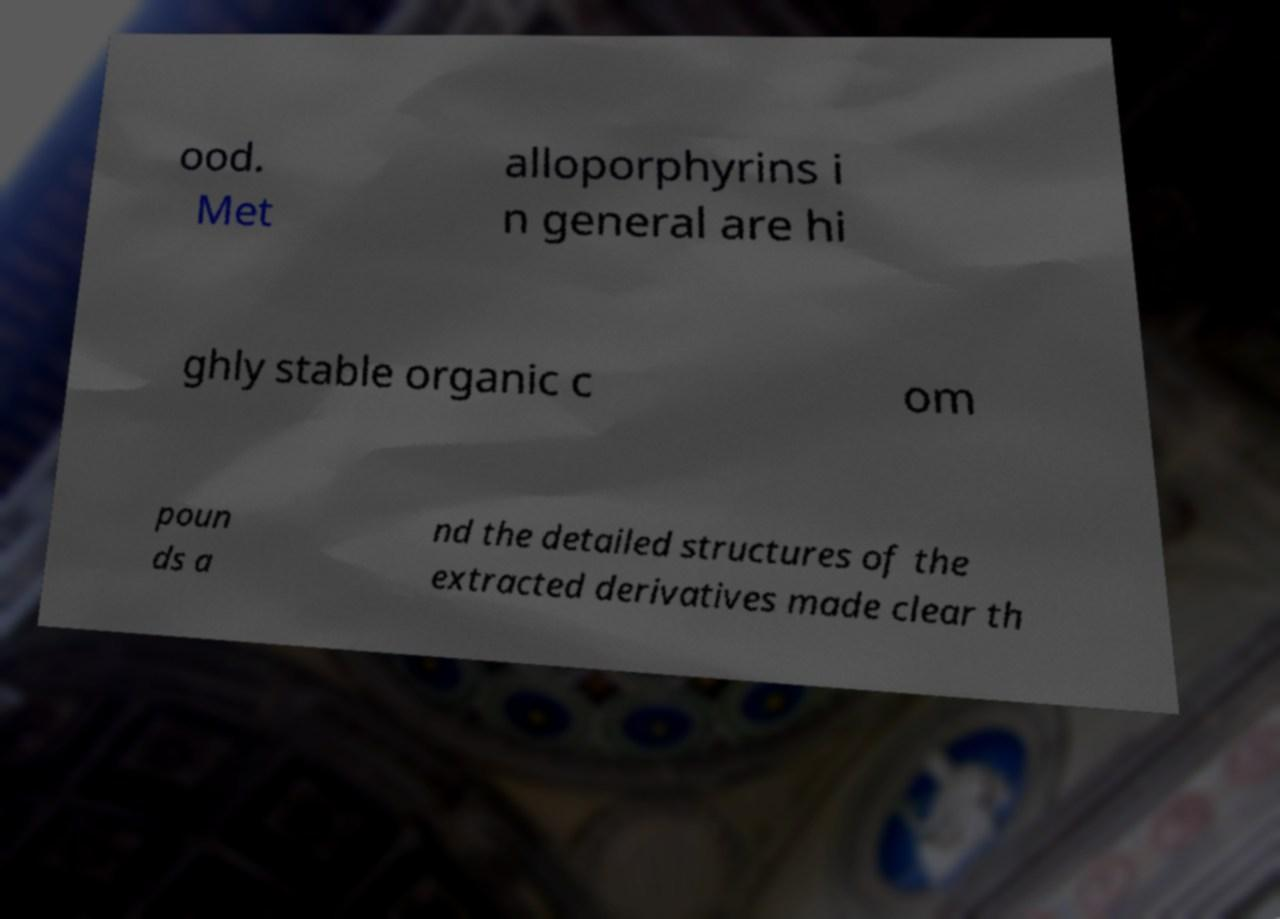What messages or text are displayed in this image? I need them in a readable, typed format. ood. Met alloporphyrins i n general are hi ghly stable organic c om poun ds a nd the detailed structures of the extracted derivatives made clear th 